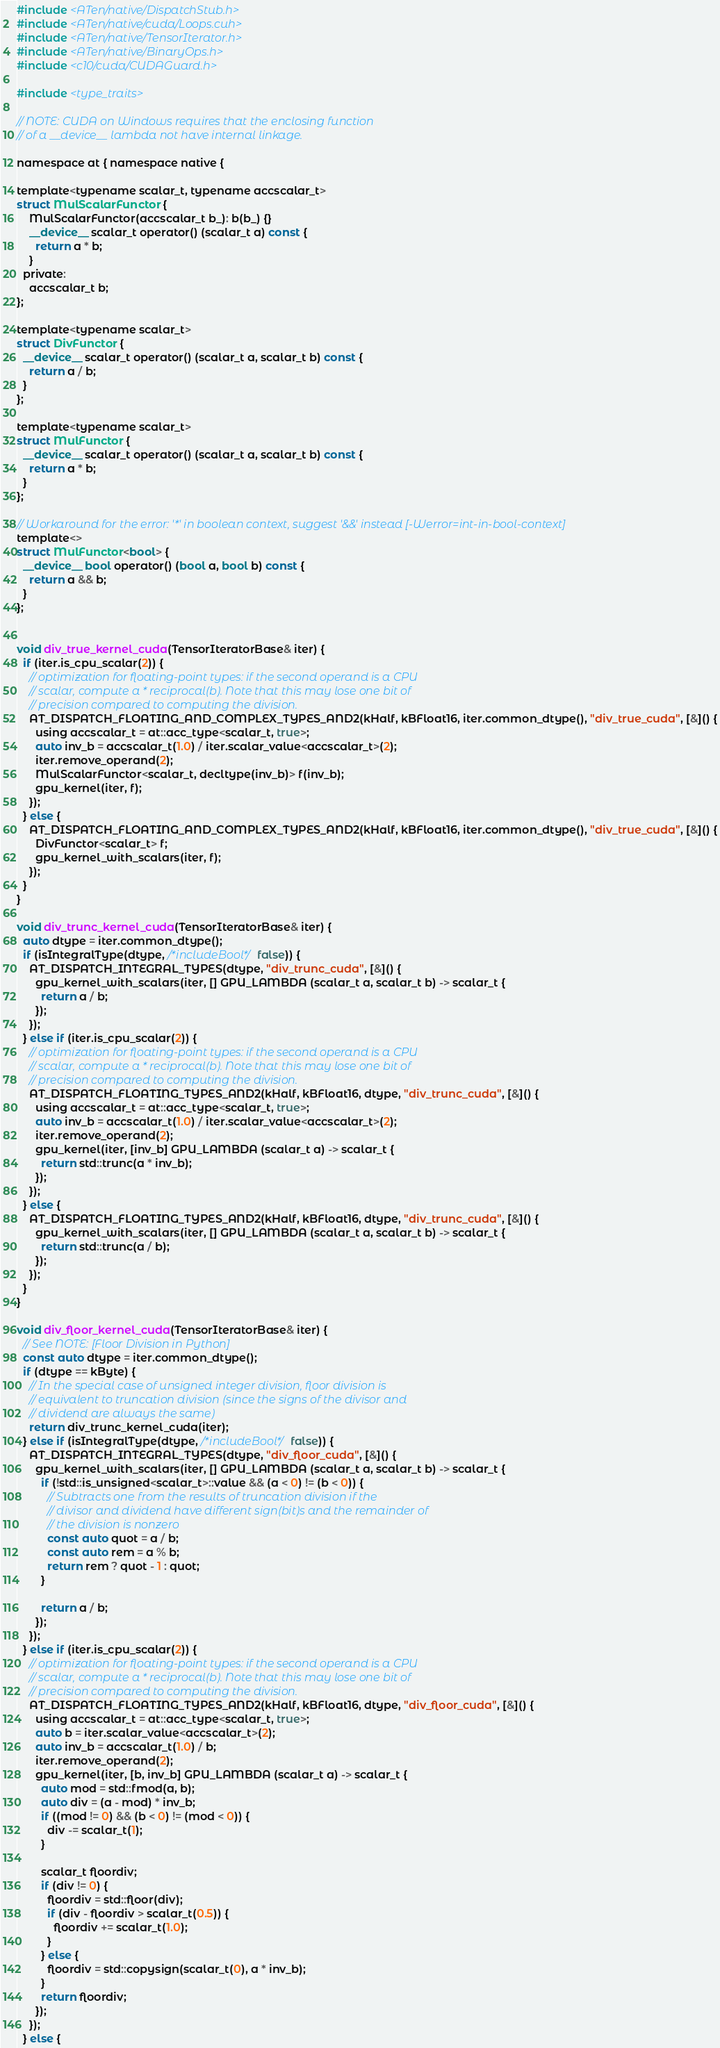Convert code to text. <code><loc_0><loc_0><loc_500><loc_500><_Cuda_>#include <ATen/native/DispatchStub.h>
#include <ATen/native/cuda/Loops.cuh>
#include <ATen/native/TensorIterator.h>
#include <ATen/native/BinaryOps.h>
#include <c10/cuda/CUDAGuard.h>

#include <type_traits>

// NOTE: CUDA on Windows requires that the enclosing function
// of a __device__ lambda not have internal linkage.

namespace at { namespace native {

template<typename scalar_t, typename accscalar_t>
struct MulScalarFunctor {
    MulScalarFunctor(accscalar_t b_): b(b_) {}
    __device__ scalar_t operator() (scalar_t a) const {
      return a * b;
    }
  private:
    accscalar_t b;
};

template<typename scalar_t>
struct DivFunctor {
  __device__ scalar_t operator() (scalar_t a, scalar_t b) const {
    return a / b;
  }
};

template<typename scalar_t>
struct MulFunctor {
  __device__ scalar_t operator() (scalar_t a, scalar_t b) const {
    return a * b;
  }
};

// Workaround for the error: '*' in boolean context, suggest '&&' instead [-Werror=int-in-bool-context]
template<>
struct MulFunctor<bool> {
  __device__ bool operator() (bool a, bool b) const {
    return a && b;
  }
};


void div_true_kernel_cuda(TensorIteratorBase& iter) {
  if (iter.is_cpu_scalar(2)) {
    // optimization for floating-point types: if the second operand is a CPU
    // scalar, compute a * reciprocal(b). Note that this may lose one bit of
    // precision compared to computing the division.
    AT_DISPATCH_FLOATING_AND_COMPLEX_TYPES_AND2(kHalf, kBFloat16, iter.common_dtype(), "div_true_cuda", [&]() {
      using accscalar_t = at::acc_type<scalar_t, true>;
      auto inv_b = accscalar_t(1.0) / iter.scalar_value<accscalar_t>(2);
      iter.remove_operand(2);
      MulScalarFunctor<scalar_t, decltype(inv_b)> f(inv_b);
      gpu_kernel(iter, f);
    });
  } else {
    AT_DISPATCH_FLOATING_AND_COMPLEX_TYPES_AND2(kHalf, kBFloat16, iter.common_dtype(), "div_true_cuda", [&]() {
      DivFunctor<scalar_t> f;
      gpu_kernel_with_scalars(iter, f);
    });
  }
}

void div_trunc_kernel_cuda(TensorIteratorBase& iter) {
  auto dtype = iter.common_dtype();
  if (isIntegralType(dtype, /*includeBool*/ false)) {
    AT_DISPATCH_INTEGRAL_TYPES(dtype, "div_trunc_cuda", [&]() {
      gpu_kernel_with_scalars(iter, [] GPU_LAMBDA (scalar_t a, scalar_t b) -> scalar_t {
        return a / b;
      });
    });
  } else if (iter.is_cpu_scalar(2)) {
    // optimization for floating-point types: if the second operand is a CPU
    // scalar, compute a * reciprocal(b). Note that this may lose one bit of
    // precision compared to computing the division.
    AT_DISPATCH_FLOATING_TYPES_AND2(kHalf, kBFloat16, dtype, "div_trunc_cuda", [&]() {
      using accscalar_t = at::acc_type<scalar_t, true>;
      auto inv_b = accscalar_t(1.0) / iter.scalar_value<accscalar_t>(2);
      iter.remove_operand(2);
      gpu_kernel(iter, [inv_b] GPU_LAMBDA (scalar_t a) -> scalar_t {
        return std::trunc(a * inv_b);
      });
    });
  } else {
    AT_DISPATCH_FLOATING_TYPES_AND2(kHalf, kBFloat16, dtype, "div_trunc_cuda", [&]() {
      gpu_kernel_with_scalars(iter, [] GPU_LAMBDA (scalar_t a, scalar_t b) -> scalar_t {
        return std::trunc(a / b);
      });
    });
  }
}

void div_floor_kernel_cuda(TensorIteratorBase& iter) {
  // See NOTE: [Floor Division in Python]
  const auto dtype = iter.common_dtype();
  if (dtype == kByte) {
    // In the special case of unsigned integer division, floor division is
    // equivalent to truncation division (since the signs of the divisor and
    // dividend are always the same)
    return div_trunc_kernel_cuda(iter);
  } else if (isIntegralType(dtype, /*includeBool*/ false)) {
    AT_DISPATCH_INTEGRAL_TYPES(dtype, "div_floor_cuda", [&]() {
      gpu_kernel_with_scalars(iter, [] GPU_LAMBDA (scalar_t a, scalar_t b) -> scalar_t {
        if (!std::is_unsigned<scalar_t>::value && (a < 0) != (b < 0)) {
          // Subtracts one from the results of truncation division if the
          // divisor and dividend have different sign(bit)s and the remainder of
          // the division is nonzero
          const auto quot = a / b;
          const auto rem = a % b;
          return rem ? quot - 1 : quot;
        }

        return a / b;
      });
    });
  } else if (iter.is_cpu_scalar(2)) {
    // optimization for floating-point types: if the second operand is a CPU
    // scalar, compute a * reciprocal(b). Note that this may lose one bit of
    // precision compared to computing the division.
    AT_DISPATCH_FLOATING_TYPES_AND2(kHalf, kBFloat16, dtype, "div_floor_cuda", [&]() {
      using accscalar_t = at::acc_type<scalar_t, true>;
      auto b = iter.scalar_value<accscalar_t>(2);
      auto inv_b = accscalar_t(1.0) / b;
      iter.remove_operand(2);
      gpu_kernel(iter, [b, inv_b] GPU_LAMBDA (scalar_t a) -> scalar_t {
        auto mod = std::fmod(a, b);
        auto div = (a - mod) * inv_b;
        if ((mod != 0) && (b < 0) != (mod < 0)) {
          div -= scalar_t(1);
        }

        scalar_t floordiv;
        if (div != 0) {
          floordiv = std::floor(div);
          if (div - floordiv > scalar_t(0.5)) {
            floordiv += scalar_t(1.0);
          }
        } else {
          floordiv = std::copysign(scalar_t(0), a * inv_b);
        }
        return floordiv;
      });
    });
  } else {</code> 